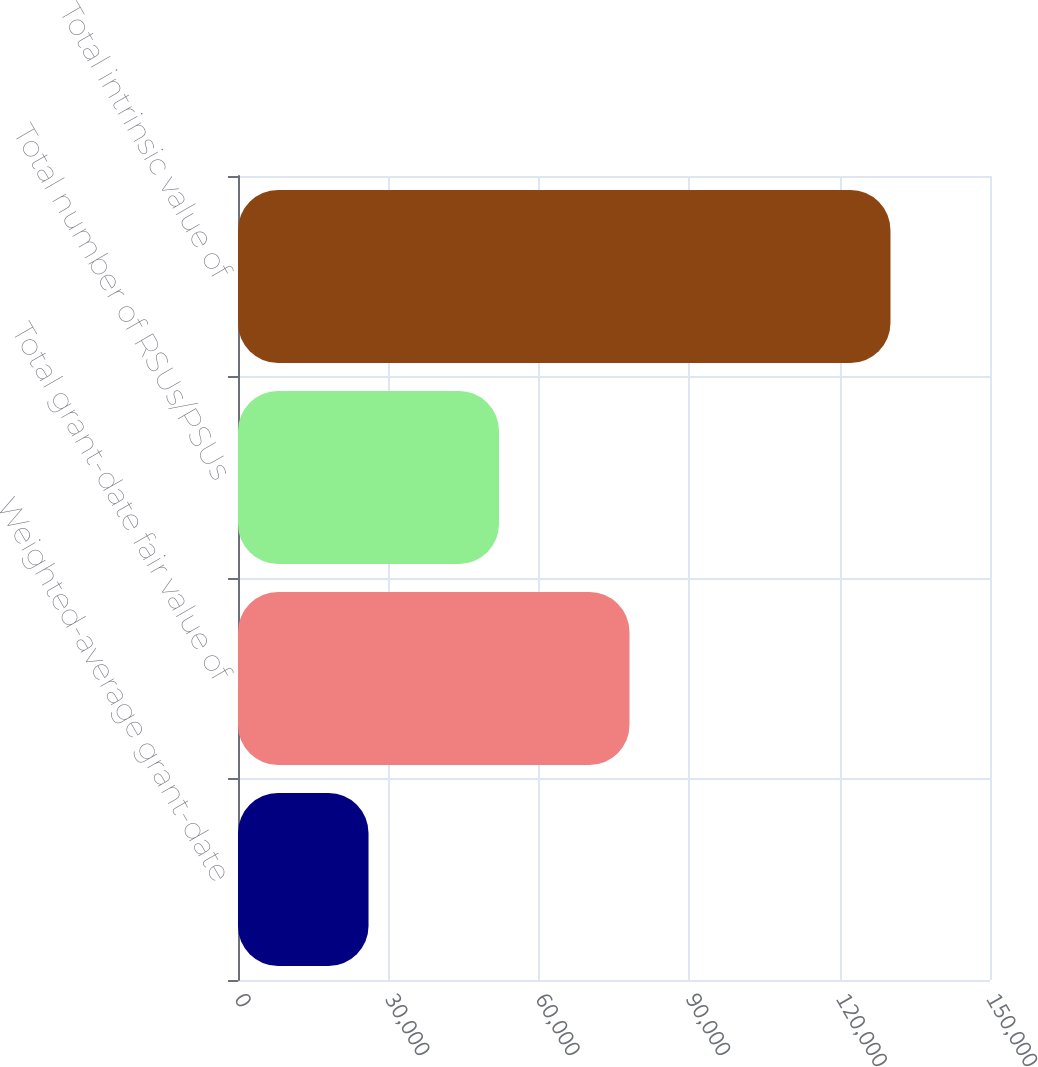<chart> <loc_0><loc_0><loc_500><loc_500><bar_chart><fcel>Weighted-average grant-date<fcel>Total grant-date fair value of<fcel>Total number of RSUs/PSUs<fcel>Total intrinsic value of<nl><fcel>26037.5<fcel>78093<fcel>52065.2<fcel>130148<nl></chart> 